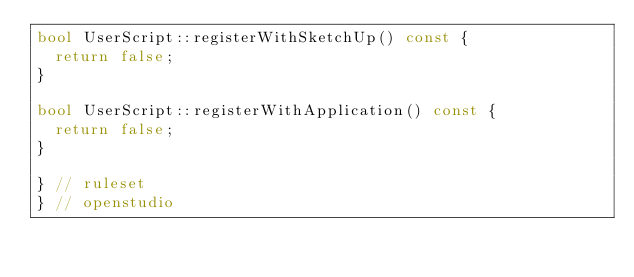<code> <loc_0><loc_0><loc_500><loc_500><_C++_>bool UserScript::registerWithSketchUp() const {
  return false;
}

bool UserScript::registerWithApplication() const {
  return false;
}

} // ruleset
} // openstudio
</code> 